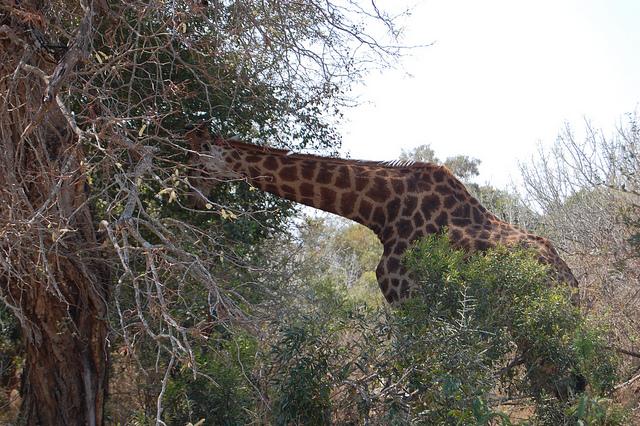What is the color of the giraffe?
Keep it brief. Brown and white. Can you see the animals head?
Be succinct. No. What is the giraffe doing?
Give a very brief answer. Eating. 